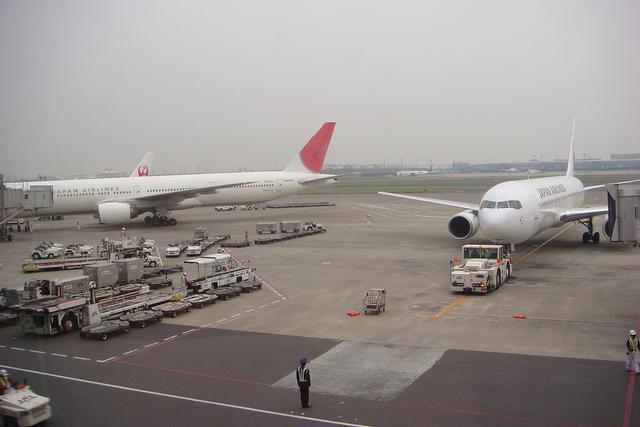How many airplanes are in the photo?
Give a very brief answer. 2. How many trucks are there?
Give a very brief answer. 2. How many keyboards are there?
Give a very brief answer. 0. 